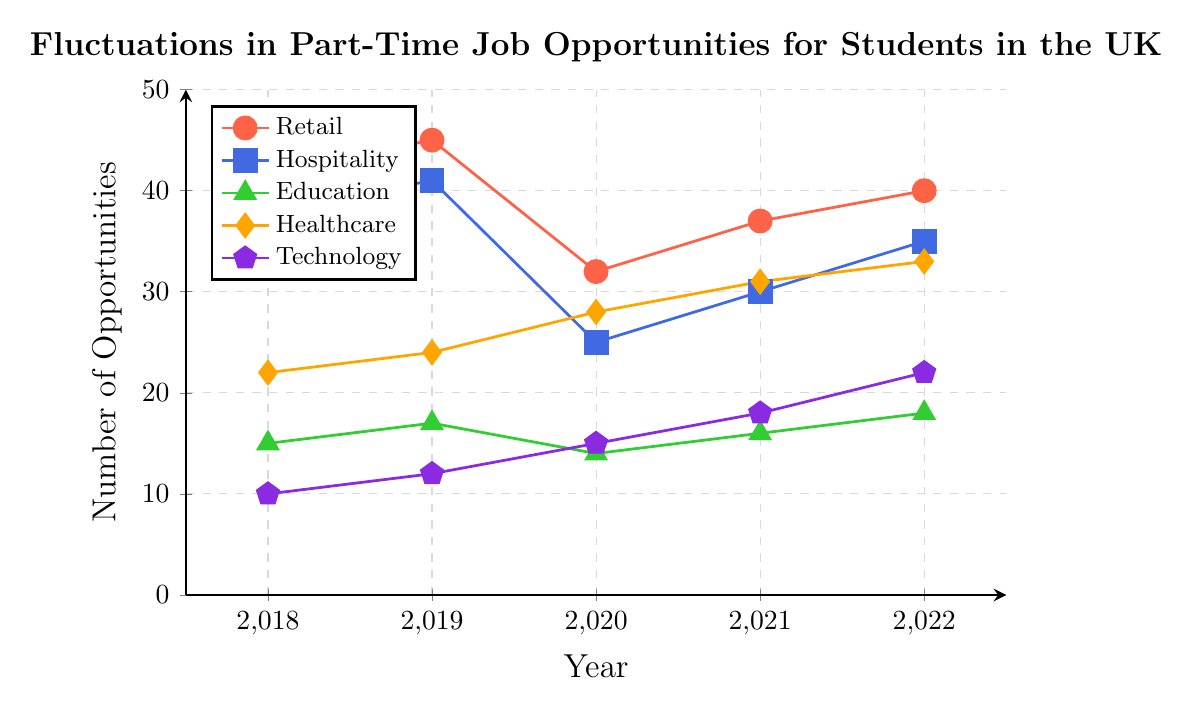What was the number of part-time job opportunities in Retail in 2019? Locate the Retail line (red) and find the data point for 2019. It is 45.
Answer: 45 Did the number of Healthcare opportunities increase or decrease from 2018 to 2019? Locate the Healthcare line (orange) and compare the data points between 2018 and 2019. It goes from 22 to 24, indicating an increase.
Answer: Increase Which sector had the highest number of part-time job opportunities in 2022? Compare the data points for 2022 across all lines. The Retail line (red) has the highest value at 40.
Answer: Retail What is the average number of Education opportunities available from 2018 to 2022? Sum the data points for Education from 2018 to 2022 (15 + 17 + 14 + 16 + 18 = 80) and then divide by the number of years (80/5).
Answer: 16 How did the number of Technology opportunities change from 2020 to 2021? Locate the Technology line (purple) and compare the data points for 2020 and 2021. It goes from 15 to 18, indicating an increase.
Answer: Increase Which sector experienced the largest drop in opportunities from 2019 to 2020? Compare the differences in the values from 2019 to 2020 for each sector. Retail drops from 45 to 32, which is the largest drop of 13.
Answer: Retail How many more part-time opportunities were available in the Healthcare sector compared to the Technology sector in 2022? Subtract the number of opportunities in Technology (22) from those in Healthcare (33) in 2022. The difference is 11.
Answer: 11 Which sectors show a consistent increase in job opportunities from 2020 to 2022? Identify sectors with increasing values each year from 2020 to 2022. Both Healthcare (28, 31, 33) and Technology (15, 18, 22) show a consistent increase.
Answer: Healthcare, Technology By how much did the Hospitality sector's opportunities change from the year with the maximum value to the year with the minimum value? Find the maximum (41 in 2019) and minimum (25 in 2020) values in Hospitality (blue) and calculate the difference (41 - 25).
Answer: 16 Which year had the lowest number of opportunities in the Education sector? Identify the lowest data point along the Education line (green). The lowest value is 14 in 2020.
Answer: 2020 